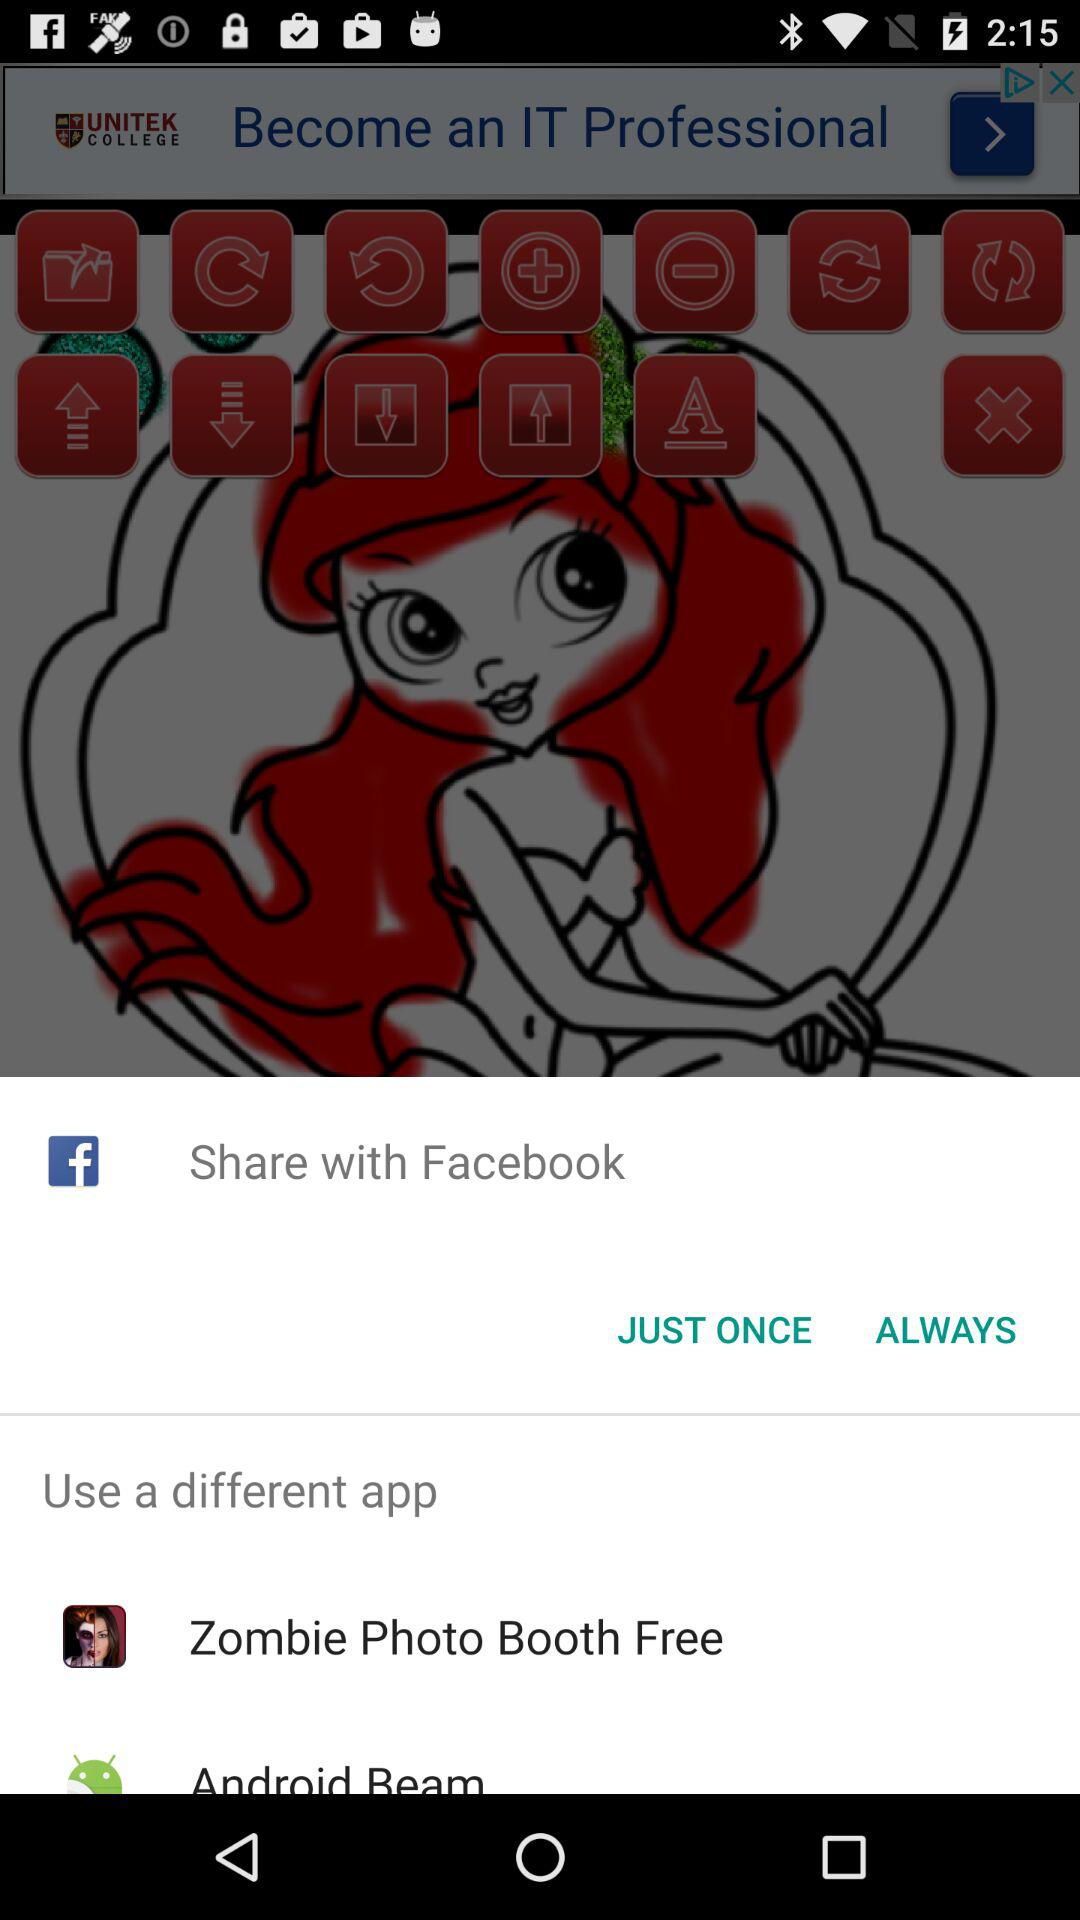What option can be used to share? The options that can be used to share are "Facebook", "Zombie Photo Booth Free" and "Android Beam". 